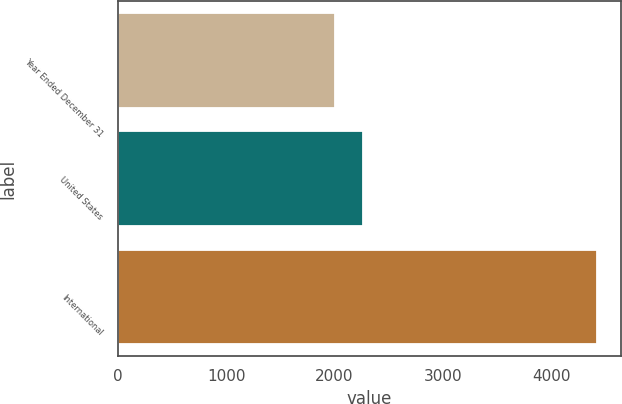<chart> <loc_0><loc_0><loc_500><loc_500><bar_chart><fcel>Year Ended December 31<fcel>United States<fcel>International<nl><fcel>2005<fcel>2268<fcel>4422<nl></chart> 